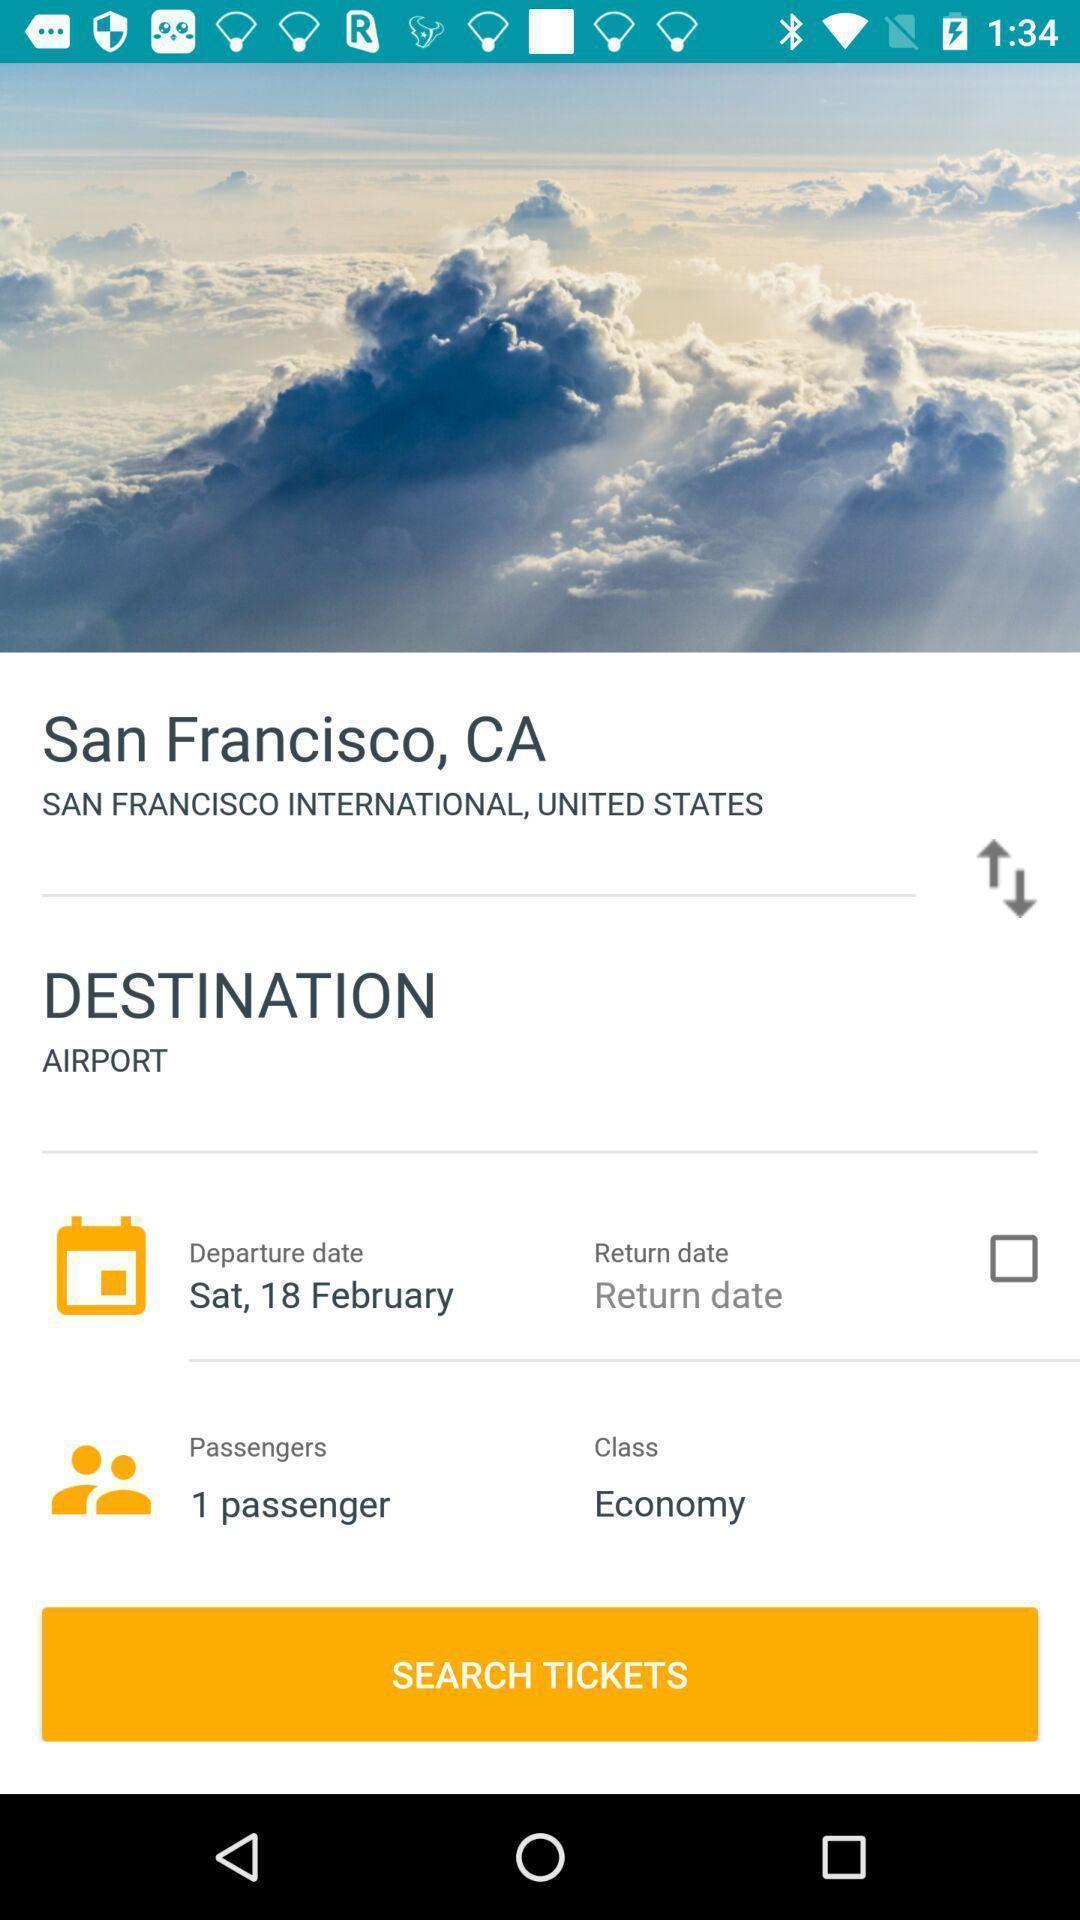Describe this image in words. Page showing option to search tickets in flight finder app. 